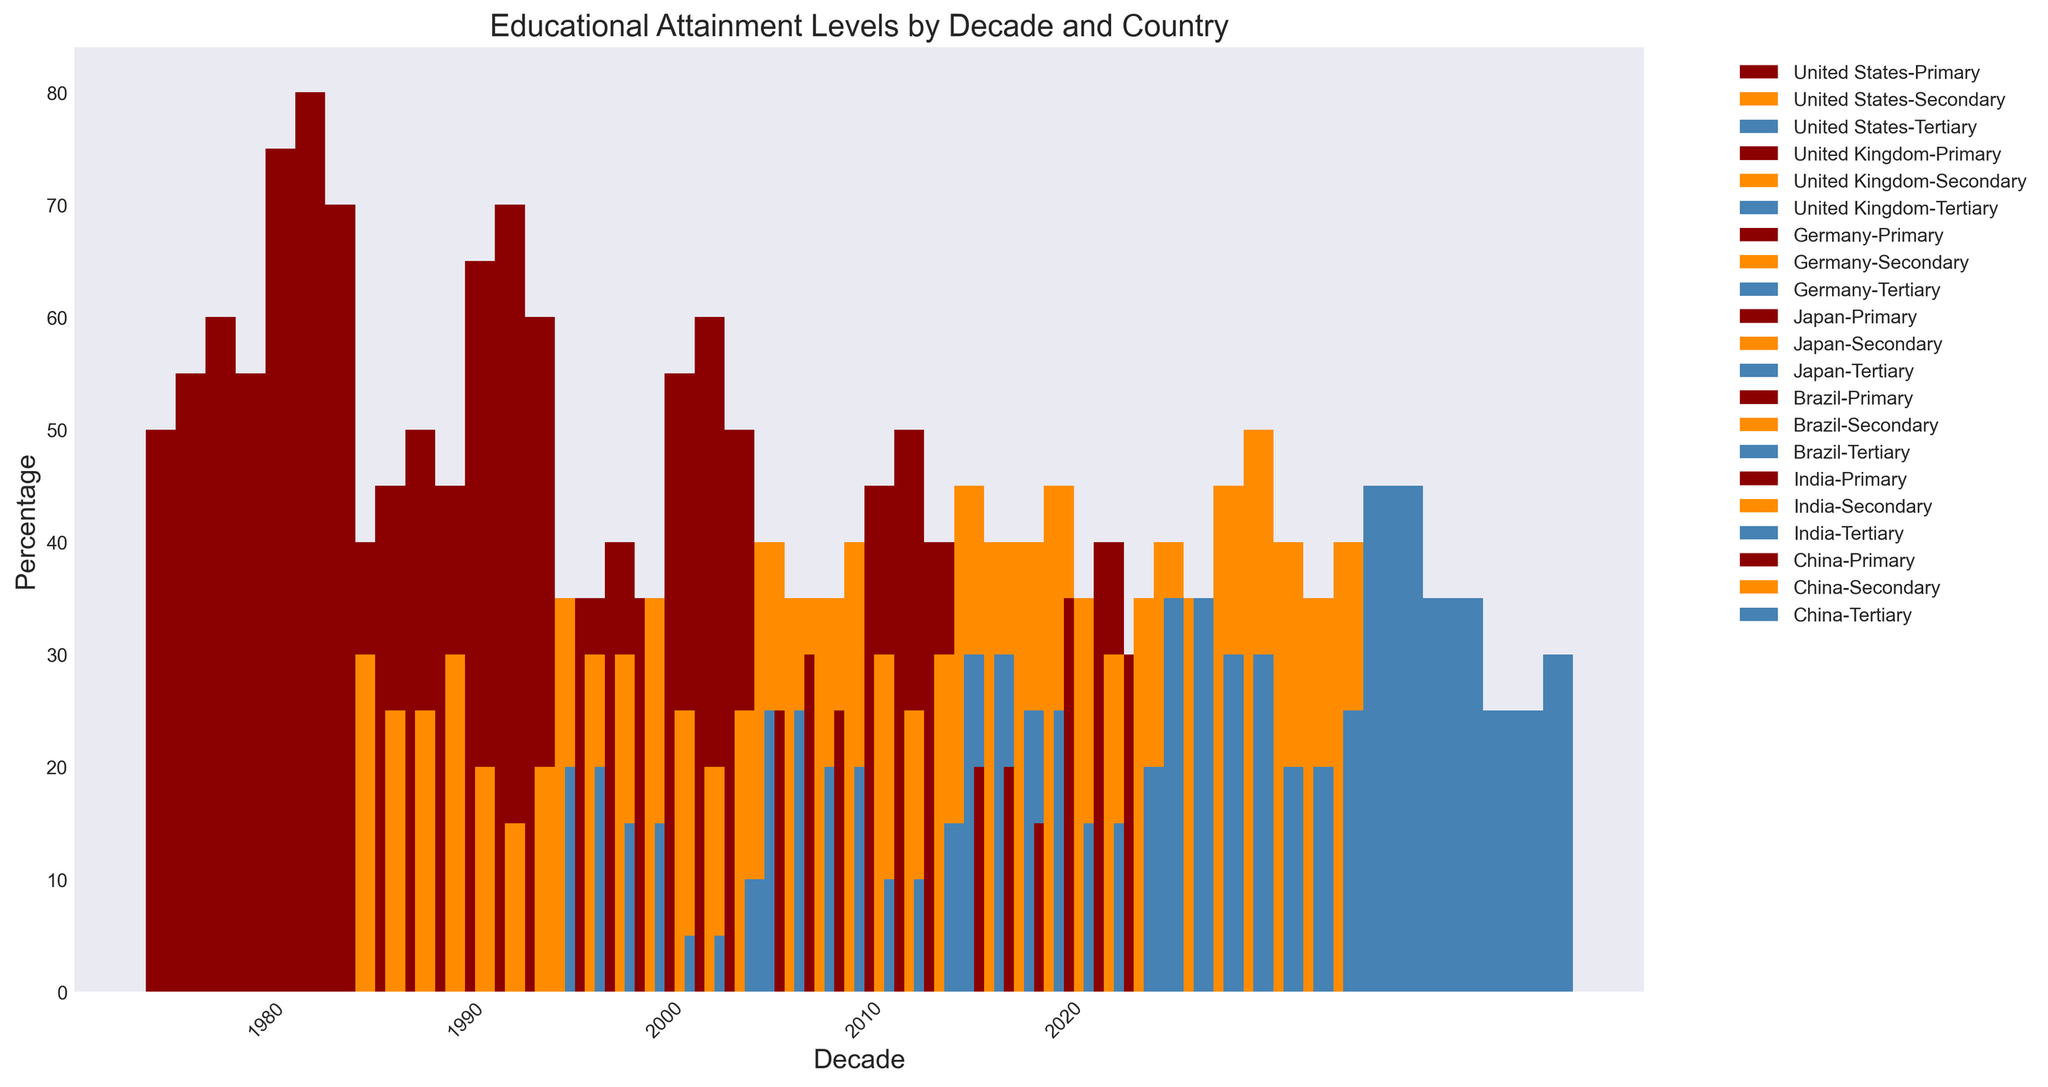What was the Educational Attainment's Primary category trend for the United States from 1980 to 2020? Observe the bar heights for the Primary category for the United States across different decades. The trend shows a consistent decrease from 50% in 1980 to 15% in 2020.
Answer: Decrease Which country had the highest percentage of Secondary education attainment in 2020? Look for the tallest bar in the Secondary category bars for 2020. Japan has the highest percentage with 50%.
Answer: Japan How does the Tertiary education level in Brazil in 2020 compare to that in 1980? Compare the bar heights for the Tertiary category in Brazil between the years 1980 and 2020. In 1980, it was 5%, and it increased to 25% in 2020.
Answer: Increased What is the sum of the Primary education percentages for the United Kingdom in 1980 and Germany in 2000? Find the Primary category bars for the UK in 1980 (55%) and Germany in 2000 (40%), then add these values together. 55 + 40 = 95.
Answer: 95 Which country had the lowest percentage of Primary education attainment in 2020? Examine the lowest bar in the Primary category for the year 2020. The lowest is Japan with 15%.
Answer: Japan What was the overall trend in Tertiary education attainment in India from 1980 to 2020? Observe the Tertiary category bars for India from 1980 (5%) to 2020 (25%). The trend shows a consistent increase.
Answer: Increase Compare the primary education levels of China in 1990 and 2020. Which one is higher? Compare the bar heights for the Primary category in China for 1990 (60%) and 2020 (30%). The percentage was higher in 1990.
Answer: 1990 What is the difference in Secondary education attainment between India and Brazil in 2020? Observe and subtract the height of the Secondary category bars for India (35%) and Brazil (40%) in 2020. 40 - 35 = 5.
Answer: 5 How did the Secondary education levels in the United States change from 1990 to 2010? Examine the bar heights for Secondary education in the US for 1990 (35%) and 2010 (45%). The percentage increased.
Answer: Increased What percentage of Primary education attainment did Germany have in 1980, and how does it compare to Japan's Tertiary education attainment in the same year? Look at the Primary category bar for Germany in 1980 (60%), and the Tertiary category bar for Japan in 1980 (15%). Germany has a higher percentage.
Answer: Germany's is higher 